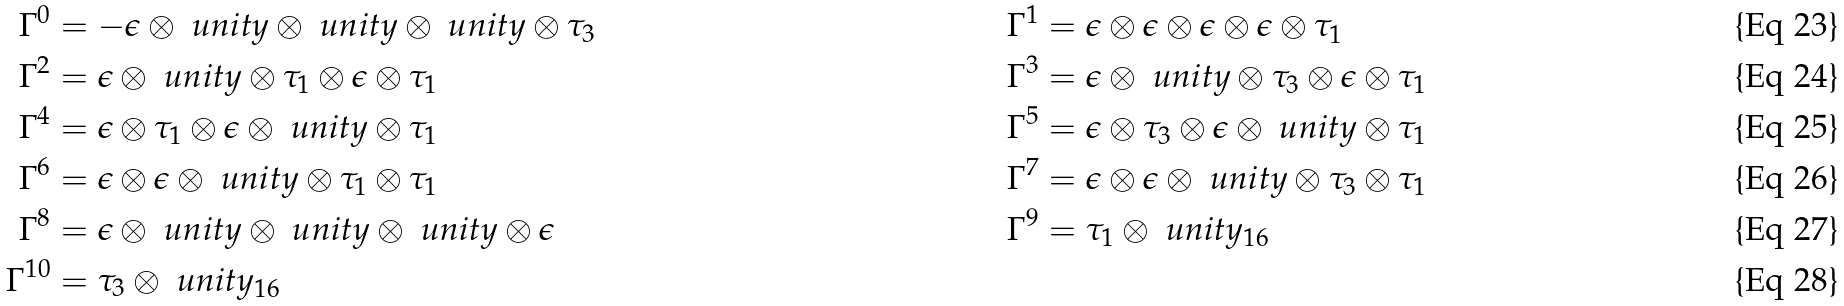Convert formula to latex. <formula><loc_0><loc_0><loc_500><loc_500>\Gamma ^ { 0 } & = - \epsilon \otimes \ u n i t y \otimes \ u n i t y \otimes \ u n i t y \otimes \tau _ { 3 } & \Gamma ^ { 1 } & = \epsilon \otimes \epsilon \otimes \epsilon \otimes \epsilon \otimes \tau _ { 1 } \\ \Gamma ^ { 2 } & = \epsilon \otimes \ u n i t y \otimes \tau _ { 1 } \otimes \epsilon \otimes \tau _ { 1 } & \Gamma ^ { 3 } & = \epsilon \otimes \ u n i t y \otimes \tau _ { 3 } \otimes \epsilon \otimes \tau _ { 1 } \\ \Gamma ^ { 4 } & = \epsilon \otimes \tau _ { 1 } \otimes \epsilon \otimes \ u n i t y \otimes \tau _ { 1 } & \Gamma ^ { 5 } & = \epsilon \otimes \tau _ { 3 } \otimes \epsilon \otimes \ u n i t y \otimes \tau _ { 1 } \\ \Gamma ^ { 6 } & = \epsilon \otimes \epsilon \otimes \ u n i t y \otimes \tau _ { 1 } \otimes \tau _ { 1 } & \Gamma ^ { 7 } & = \epsilon \otimes \epsilon \otimes \ u n i t y \otimes \tau _ { 3 } \otimes \tau _ { 1 } \\ \Gamma ^ { 8 } & = \epsilon \otimes \ u n i t y \otimes \ u n i t y \otimes \ u n i t y \otimes \epsilon & \Gamma ^ { 9 } & = \tau _ { 1 } \otimes \ u n i t y _ { 1 6 } \\ \Gamma ^ { 1 0 } & = \tau _ { 3 } \otimes \ u n i t y _ { 1 6 }</formula> 